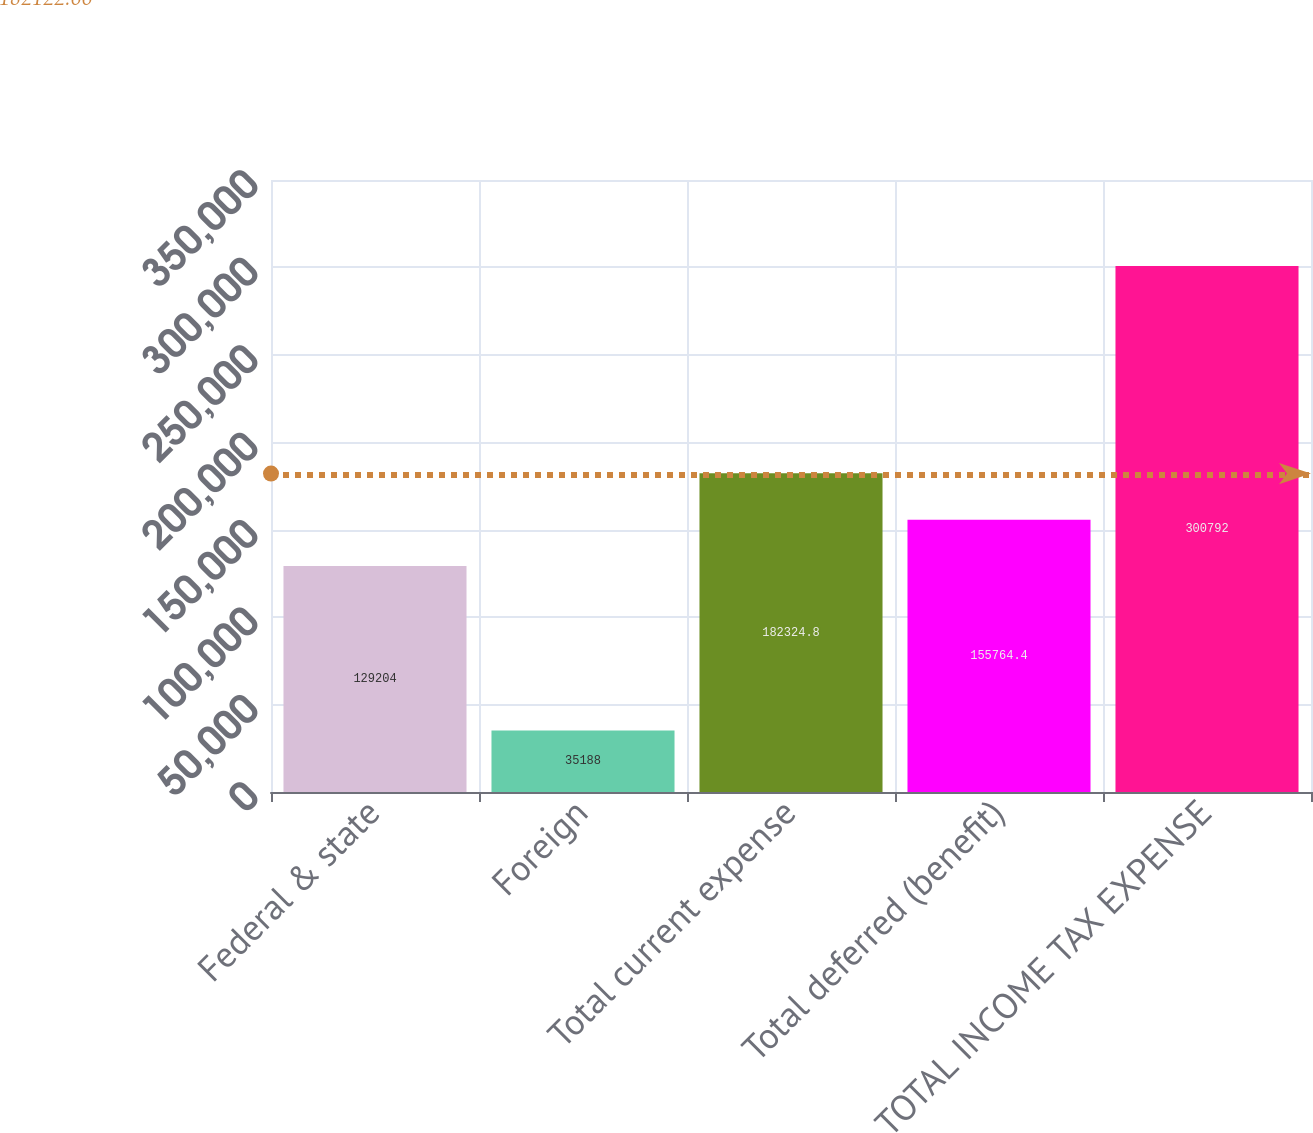<chart> <loc_0><loc_0><loc_500><loc_500><bar_chart><fcel>Federal & state<fcel>Foreign<fcel>Total current expense<fcel>Total deferred (benefit)<fcel>TOTAL INCOME TAX EXPENSE<nl><fcel>129204<fcel>35188<fcel>182325<fcel>155764<fcel>300792<nl></chart> 